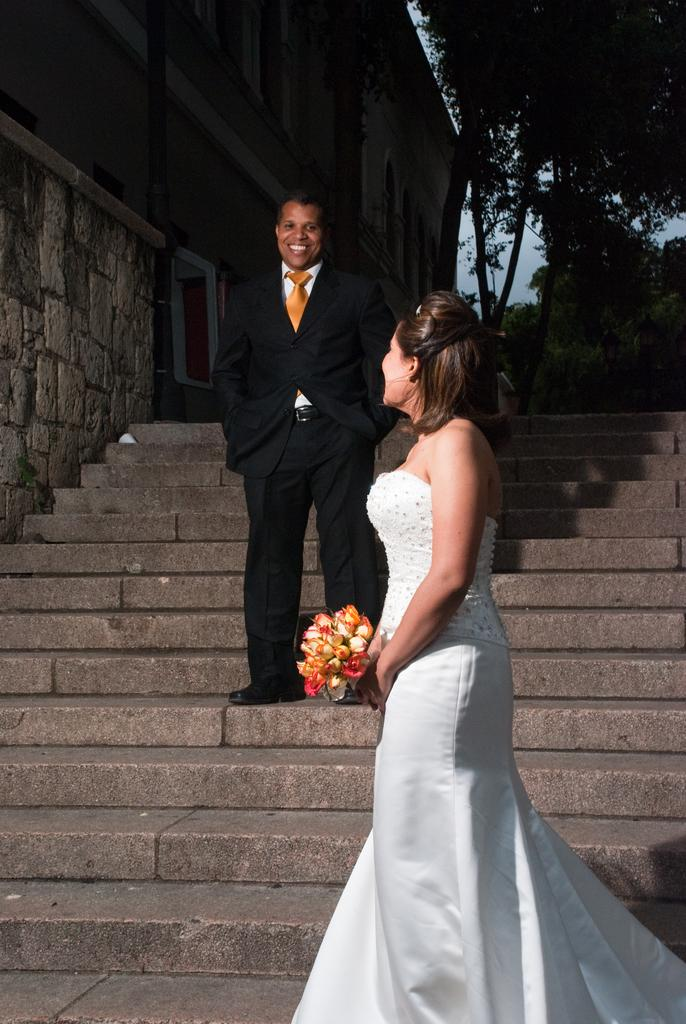What are the two people in the image doing? The two people are on the staircase in the center of the image. What can be seen in the background of the image? There are trees in the background of the image. What is located to the left side of the image? There is a building to the left side of the image. What type of paper is being used by the people on the staircase in the image? There is no paper visible in the image; the two people are simply on the staircase. 